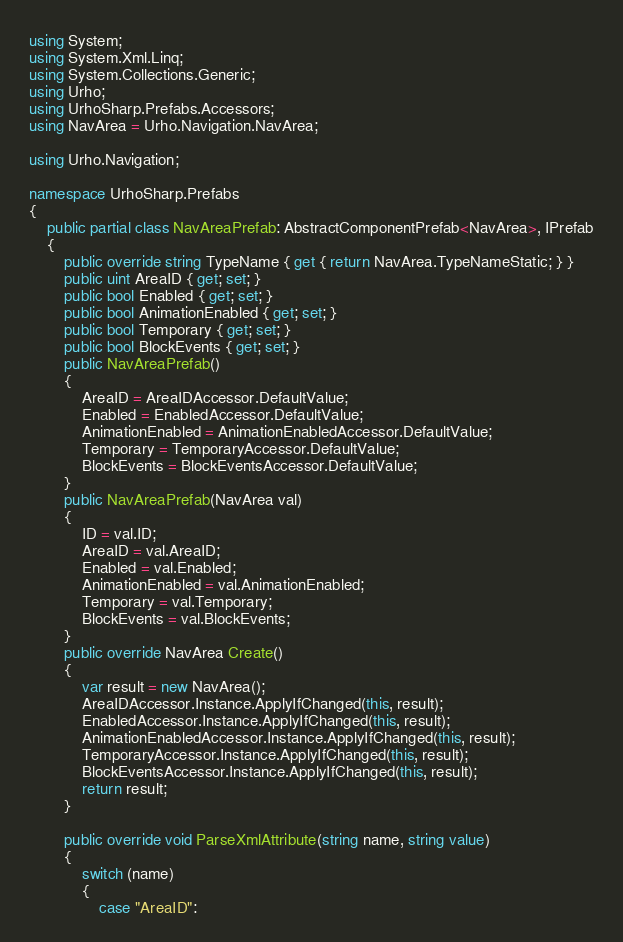<code> <loc_0><loc_0><loc_500><loc_500><_C#_>using System;
using System.Xml.Linq;
using System.Collections.Generic;
using Urho;
using UrhoSharp.Prefabs.Accessors;
using NavArea = Urho.Navigation.NavArea;

using Urho.Navigation;

namespace UrhoSharp.Prefabs
{
    public partial class NavAreaPrefab: AbstractComponentPrefab<NavArea>, IPrefab
    {
        public override string TypeName { get { return NavArea.TypeNameStatic; } }
        public uint AreaID { get; set; }
        public bool Enabled { get; set; }
        public bool AnimationEnabled { get; set; }
        public bool Temporary { get; set; }
        public bool BlockEvents { get; set; }
        public NavAreaPrefab()
        {
            AreaID = AreaIDAccessor.DefaultValue;
            Enabled = EnabledAccessor.DefaultValue;
            AnimationEnabled = AnimationEnabledAccessor.DefaultValue;
            Temporary = TemporaryAccessor.DefaultValue;
            BlockEvents = BlockEventsAccessor.DefaultValue;
        }
        public NavAreaPrefab(NavArea val)
        {
            ID = val.ID;
            AreaID = val.AreaID;
            Enabled = val.Enabled;
            AnimationEnabled = val.AnimationEnabled;
            Temporary = val.Temporary;
            BlockEvents = val.BlockEvents;
        }
        public override NavArea Create()
        {
            var result = new NavArea();
            AreaIDAccessor.Instance.ApplyIfChanged(this, result);
            EnabledAccessor.Instance.ApplyIfChanged(this, result);
            AnimationEnabledAccessor.Instance.ApplyIfChanged(this, result);
            TemporaryAccessor.Instance.ApplyIfChanged(this, result);
            BlockEventsAccessor.Instance.ApplyIfChanged(this, result);
            return result;
        }

        public override void ParseXmlAttribute(string name, string value)
        {
            switch (name)
            {
                case "AreaID":</code> 